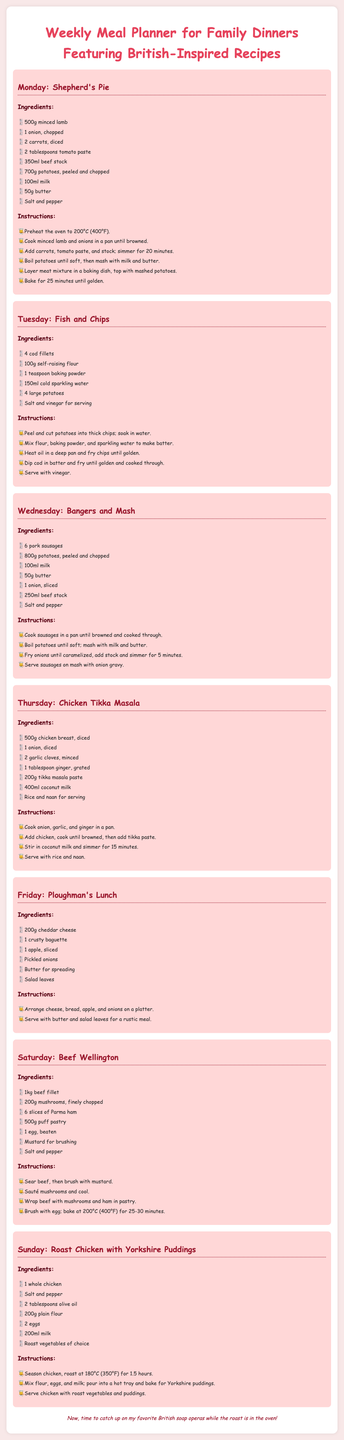What is the main dish for Monday? The main dish for Monday is Shepherd's Pie, as indicated at the top of the Monday section.
Answer: Shepherd's Pie How many ingredients are listed for Fish and Chips? There are six ingredients listed under the Fish and Chips section.
Answer: 6 What temperature should the oven be preheated to for Shepherd's Pie? The oven should be preheated to 200°C (400°F) as stated in the instructions for Shepherd's Pie.
Answer: 200°C (400°F) Which day features Bangers and Mash? The section titled Bangers and Mash is under Wednesday.
Answer: Wednesday What type of cheese is used in the Ploughman's Lunch? The recipe specifies using cheddar cheese for the Ploughman's Lunch.
Answer: Cheddar cheese How long should the chicken roast on Sunday? The recipe mentions that the chicken should roast for 1.5 hours.
Answer: 1.5 hours What is used for serving with Chicken Tikka Masala? The recipe suggests serving Chicken Tikka Masala with rice and naan.
Answer: Rice and naan What is the total number of days this meal planner covers? The meal planner includes seven days, listed from Monday to Sunday.
Answer: 7 